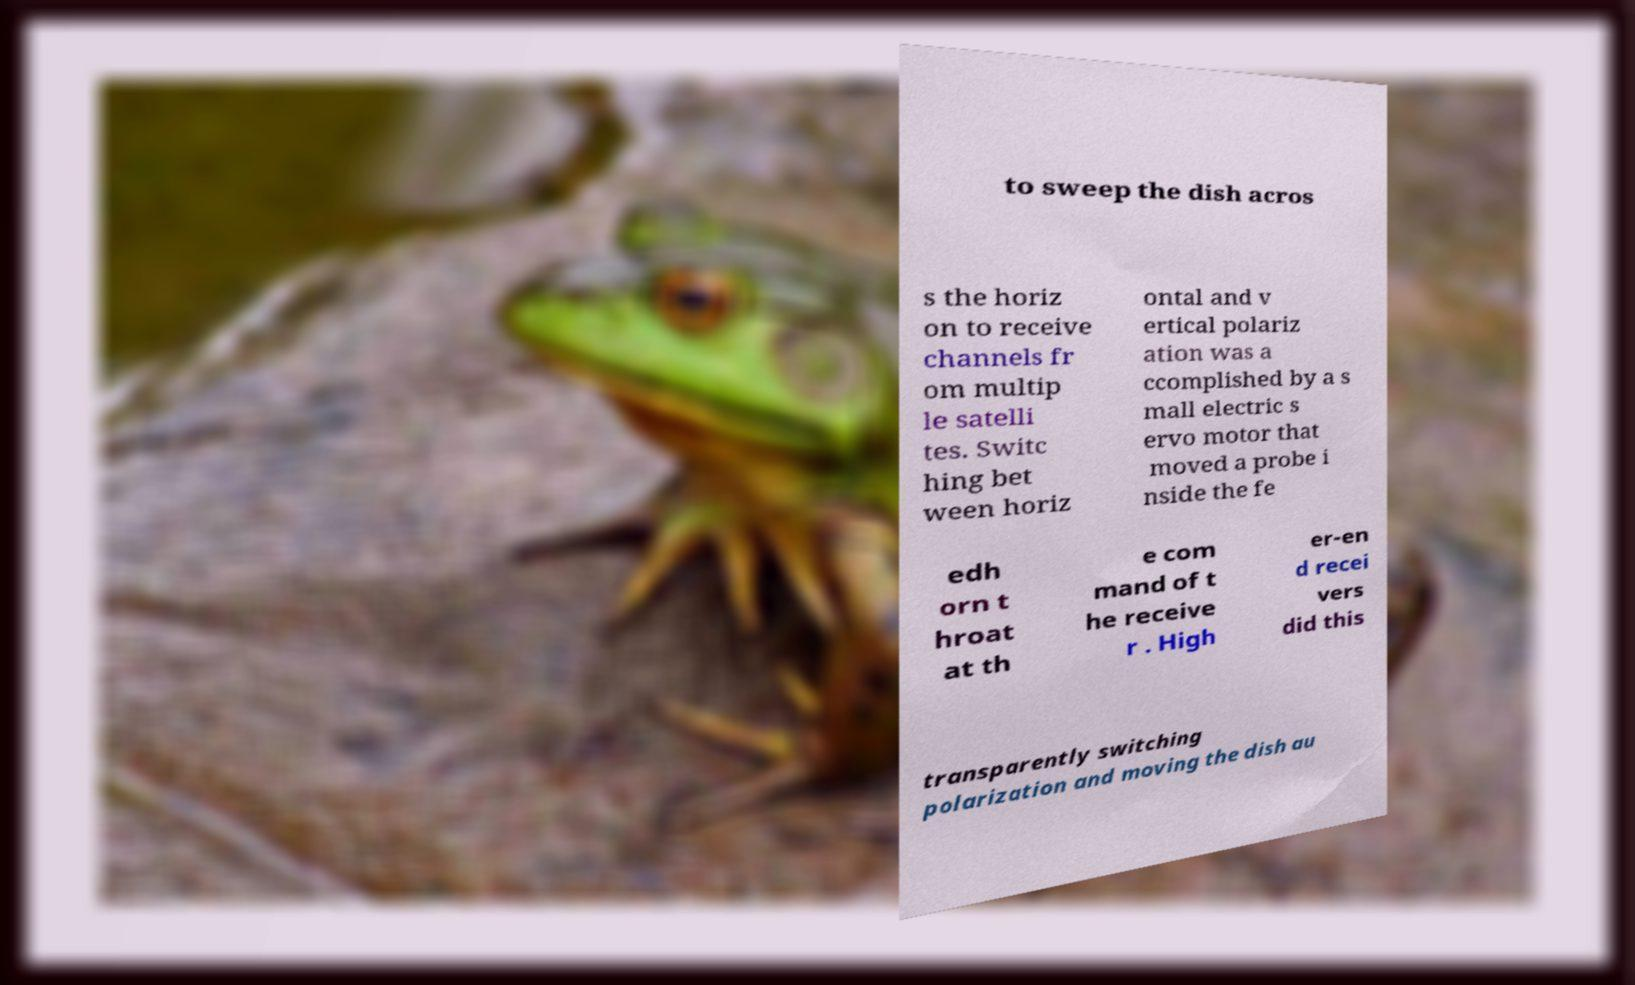Could you extract and type out the text from this image? to sweep the dish acros s the horiz on to receive channels fr om multip le satelli tes. Switc hing bet ween horiz ontal and v ertical polariz ation was a ccomplished by a s mall electric s ervo motor that moved a probe i nside the fe edh orn t hroat at th e com mand of t he receive r . High er-en d recei vers did this transparently switching polarization and moving the dish au 